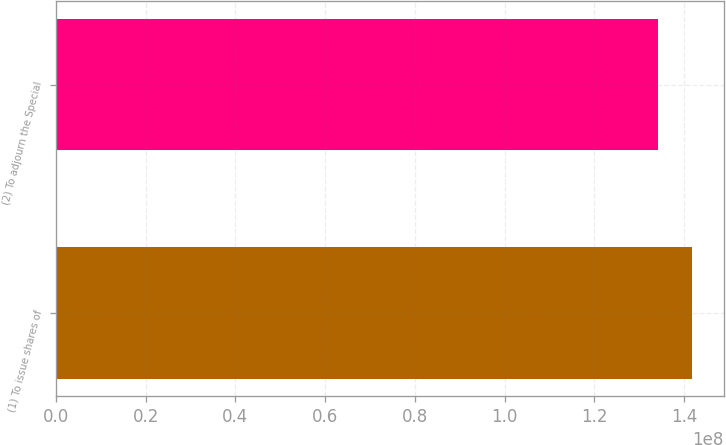Convert chart. <chart><loc_0><loc_0><loc_500><loc_500><bar_chart><fcel>(1) To issue shares of<fcel>(2) To adjourn the Special<nl><fcel>1.41729e+08<fcel>1.34082e+08<nl></chart> 